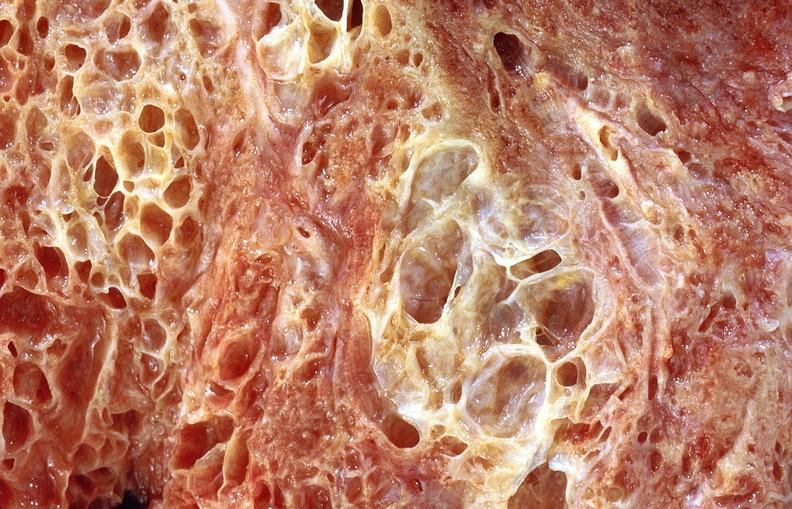does this image show lung fibrosis, scleroderma?
Answer the question using a single word or phrase. Yes 